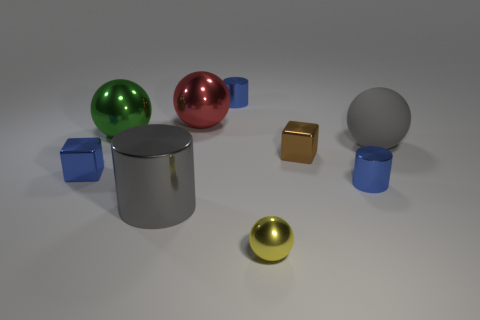Subtract all blue cylinders. How many cylinders are left? 1 Add 1 green spheres. How many objects exist? 10 Subtract all gray cylinders. How many cylinders are left? 2 Subtract all purple blocks. How many blue cylinders are left? 2 Subtract all cubes. How many objects are left? 7 Subtract all blue shiny cubes. Subtract all small blue blocks. How many objects are left? 7 Add 7 tiny brown cubes. How many tiny brown cubes are left? 8 Add 3 large red balls. How many large red balls exist? 4 Subtract 0 green cubes. How many objects are left? 9 Subtract 3 balls. How many balls are left? 1 